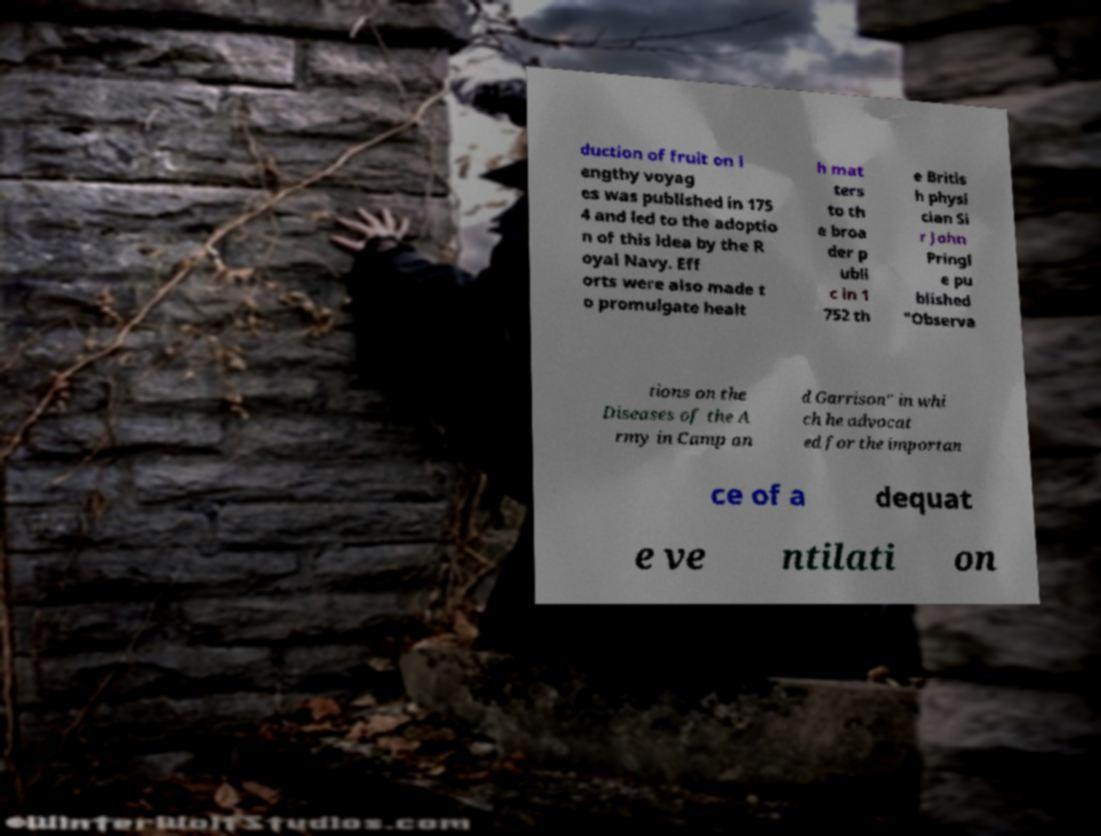Could you extract and type out the text from this image? duction of fruit on l engthy voyag es was published in 175 4 and led to the adoptio n of this idea by the R oyal Navy. Eff orts were also made t o promulgate healt h mat ters to th e broa der p ubli c in 1 752 th e Britis h physi cian Si r John Pringl e pu blished "Observa tions on the Diseases of the A rmy in Camp an d Garrison" in whi ch he advocat ed for the importan ce of a dequat e ve ntilati on 